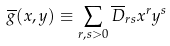<formula> <loc_0><loc_0><loc_500><loc_500>\overline { g } ( x , y ) \equiv \sum _ { r , s > 0 } \overline { D } _ { r s } x ^ { r } y ^ { s } \,</formula> 